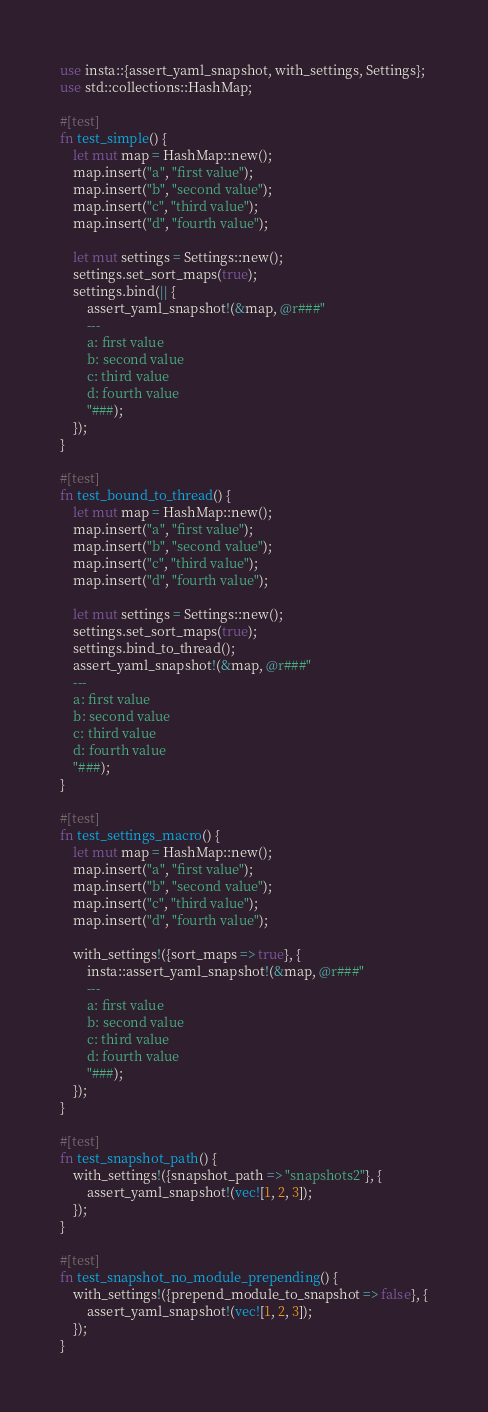Convert code to text. <code><loc_0><loc_0><loc_500><loc_500><_Rust_>use insta::{assert_yaml_snapshot, with_settings, Settings};
use std::collections::HashMap;

#[test]
fn test_simple() {
    let mut map = HashMap::new();
    map.insert("a", "first value");
    map.insert("b", "second value");
    map.insert("c", "third value");
    map.insert("d", "fourth value");

    let mut settings = Settings::new();
    settings.set_sort_maps(true);
    settings.bind(|| {
        assert_yaml_snapshot!(&map, @r###"
        ---
        a: first value
        b: second value
        c: third value
        d: fourth value
        "###);
    });
}

#[test]
fn test_bound_to_thread() {
    let mut map = HashMap::new();
    map.insert("a", "first value");
    map.insert("b", "second value");
    map.insert("c", "third value");
    map.insert("d", "fourth value");

    let mut settings = Settings::new();
    settings.set_sort_maps(true);
    settings.bind_to_thread();
    assert_yaml_snapshot!(&map, @r###"
    ---
    a: first value
    b: second value
    c: third value
    d: fourth value
    "###);
}

#[test]
fn test_settings_macro() {
    let mut map = HashMap::new();
    map.insert("a", "first value");
    map.insert("b", "second value");
    map.insert("c", "third value");
    map.insert("d", "fourth value");

    with_settings!({sort_maps => true}, {
        insta::assert_yaml_snapshot!(&map, @r###"
        ---
        a: first value
        b: second value
        c: third value
        d: fourth value
        "###);
    });
}

#[test]
fn test_snapshot_path() {
    with_settings!({snapshot_path => "snapshots2"}, {
        assert_yaml_snapshot!(vec![1, 2, 3]);
    });
}

#[test]
fn test_snapshot_no_module_prepending() {
    with_settings!({prepend_module_to_snapshot => false}, {
        assert_yaml_snapshot!(vec![1, 2, 3]);
    });
}
</code> 